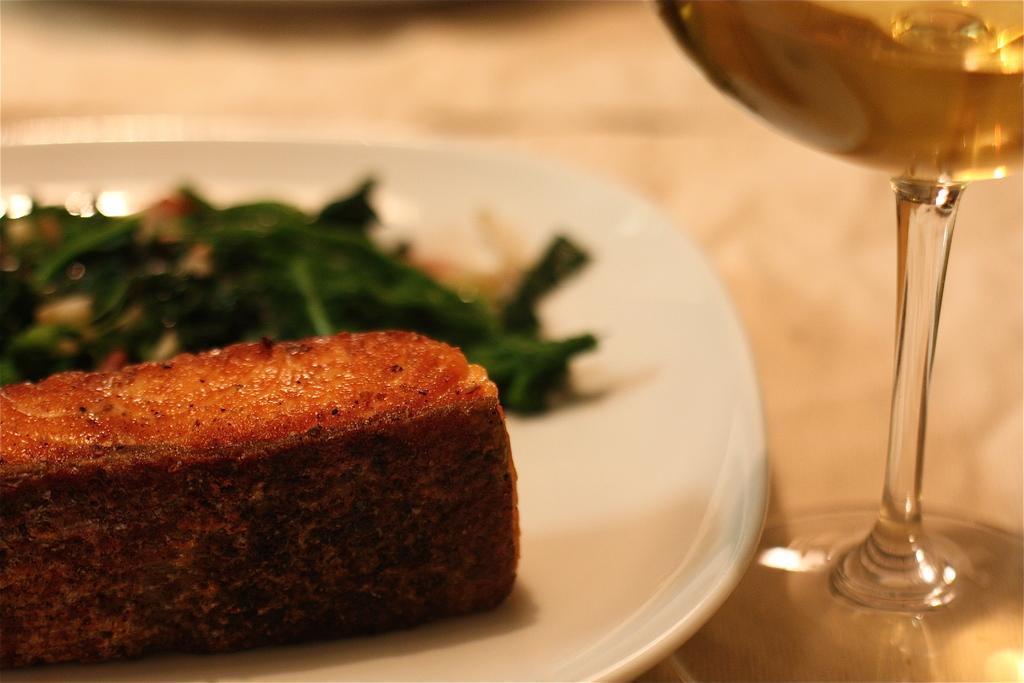Please provide a concise description of this image. In this image we can see some food items are kept on the white plate and we can see a glass with a drink it is kept on the surface. This part of the image is slightly blurred. 